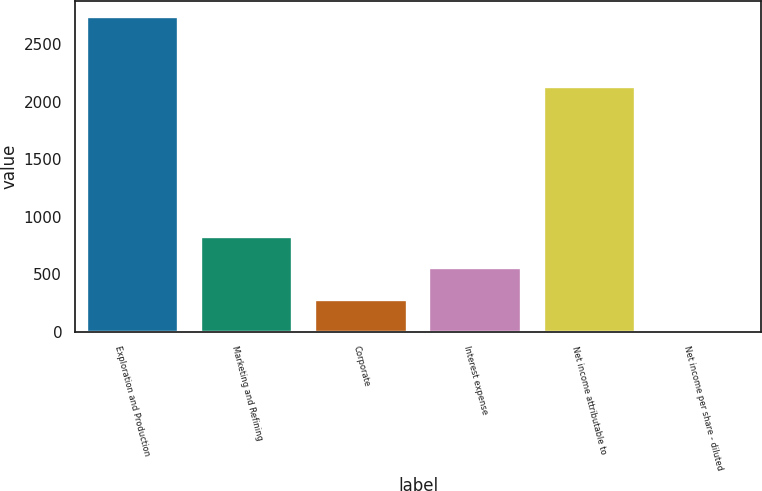Convert chart to OTSL. <chart><loc_0><loc_0><loc_500><loc_500><bar_chart><fcel>Exploration and Production<fcel>Marketing and Refining<fcel>Corporate<fcel>Interest expense<fcel>Net income attributable to<fcel>Net income per share - diluted<nl><fcel>2736<fcel>825.32<fcel>279.42<fcel>552.37<fcel>2125<fcel>6.47<nl></chart> 